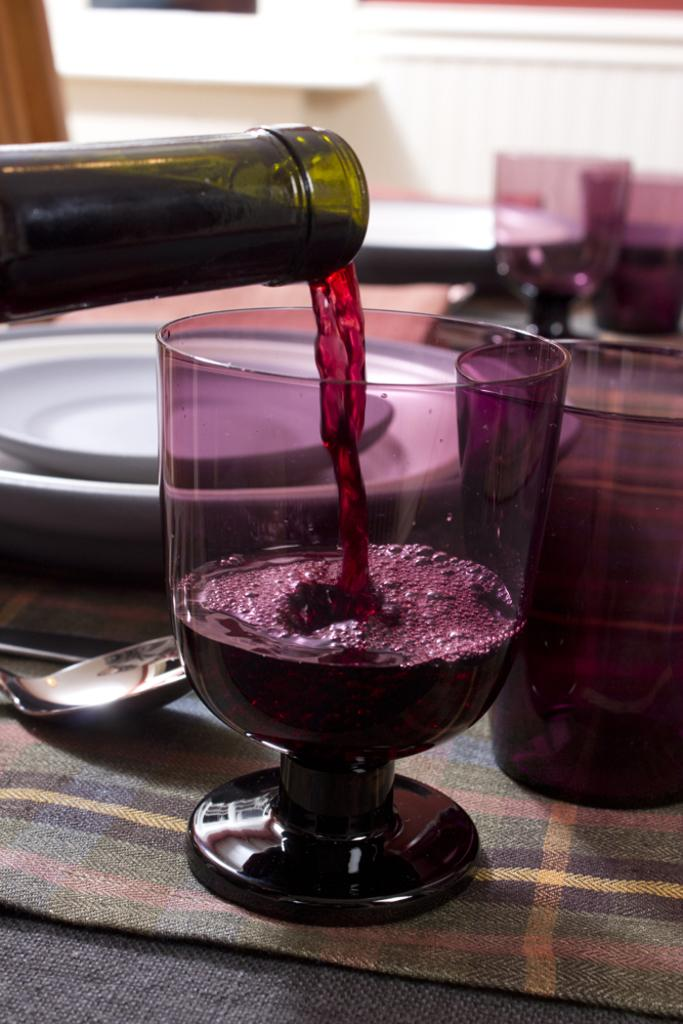What is on the table in the image? There is a glass, plates, spoons, and a bottle on the table. What might be used for drinking in the image? The glass on the table might be used for drinking. What might be used for eating in the image? The plates and spoons on the table might be used for eating. What is the shape of the bottle on the table? The shape of the bottle cannot be determined from the image alone. How does the lock on the table work in the image? There is no lock present on the table in the image. What type of form does the cap on the table take in the image? There is no cap present on the table in the image. 